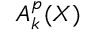<formula> <loc_0><loc_0><loc_500><loc_500>A _ { k } ^ { p } ( X )</formula> 